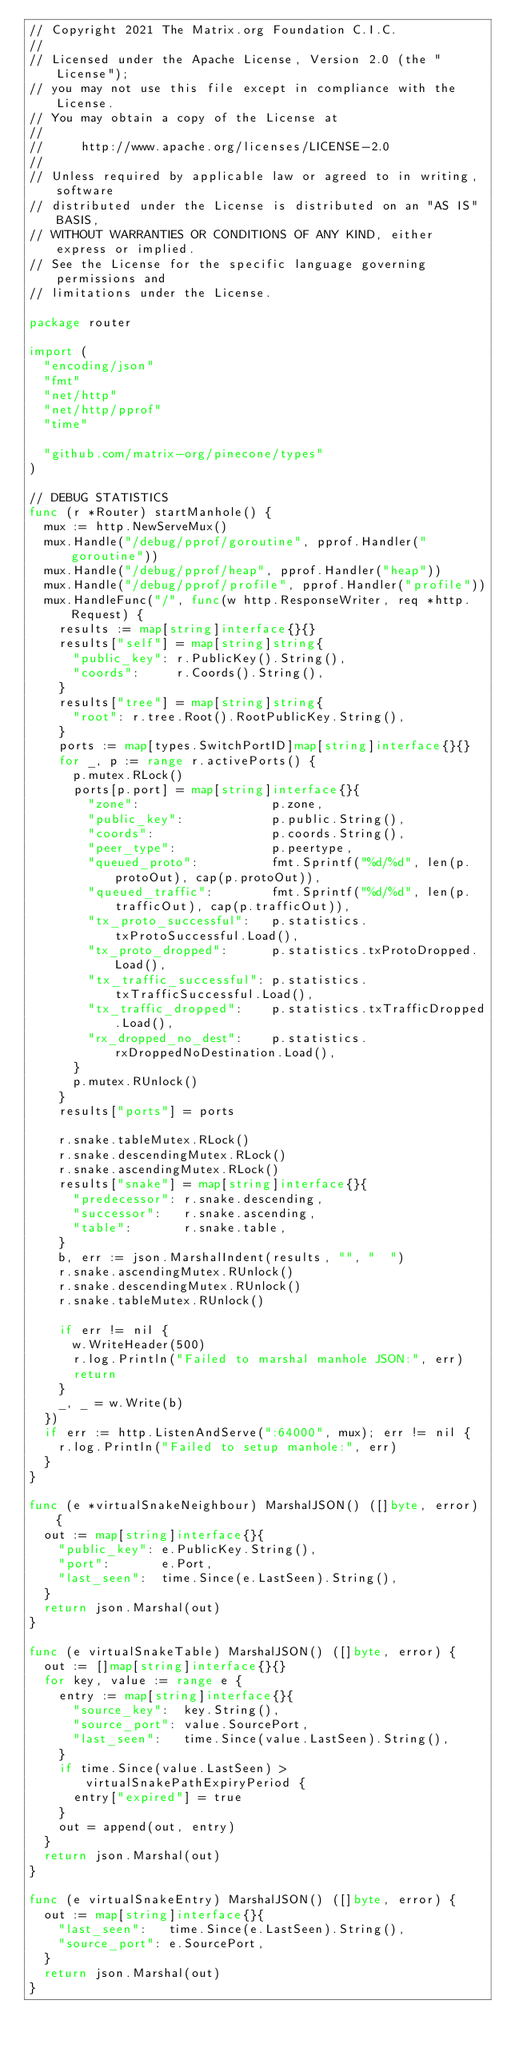<code> <loc_0><loc_0><loc_500><loc_500><_Go_>// Copyright 2021 The Matrix.org Foundation C.I.C.
//
// Licensed under the Apache License, Version 2.0 (the "License");
// you may not use this file except in compliance with the License.
// You may obtain a copy of the License at
//
//     http://www.apache.org/licenses/LICENSE-2.0
//
// Unless required by applicable law or agreed to in writing, software
// distributed under the License is distributed on an "AS IS" BASIS,
// WITHOUT WARRANTIES OR CONDITIONS OF ANY KIND, either express or implied.
// See the License for the specific language governing permissions and
// limitations under the License.

package router

import (
	"encoding/json"
	"fmt"
	"net/http"
	"net/http/pprof"
	"time"

	"github.com/matrix-org/pinecone/types"
)

// DEBUG STATISTICS
func (r *Router) startManhole() {
	mux := http.NewServeMux()
	mux.Handle("/debug/pprof/goroutine", pprof.Handler("goroutine"))
	mux.Handle("/debug/pprof/heap", pprof.Handler("heap"))
	mux.Handle("/debug/pprof/profile", pprof.Handler("profile"))
	mux.HandleFunc("/", func(w http.ResponseWriter, req *http.Request) {
		results := map[string]interface{}{}
		results["self"] = map[string]string{
			"public_key": r.PublicKey().String(),
			"coords":     r.Coords().String(),
		}
		results["tree"] = map[string]string{
			"root": r.tree.Root().RootPublicKey.String(),
		}
		ports := map[types.SwitchPortID]map[string]interface{}{}
		for _, p := range r.activePorts() {
			p.mutex.RLock()
			ports[p.port] = map[string]interface{}{
				"zone":                  p.zone,
				"public_key":            p.public.String(),
				"coords":                p.coords.String(),
				"peer_type":             p.peertype,
				"queued_proto":          fmt.Sprintf("%d/%d", len(p.protoOut), cap(p.protoOut)),
				"queued_traffic":        fmt.Sprintf("%d/%d", len(p.trafficOut), cap(p.trafficOut)),
				"tx_proto_successful":   p.statistics.txProtoSuccessful.Load(),
				"tx_proto_dropped":      p.statistics.txProtoDropped.Load(),
				"tx_traffic_successful": p.statistics.txTrafficSuccessful.Load(),
				"tx_traffic_dropped":    p.statistics.txTrafficDropped.Load(),
				"rx_dropped_no_dest":    p.statistics.rxDroppedNoDestination.Load(),
			}
			p.mutex.RUnlock()
		}
		results["ports"] = ports

		r.snake.tableMutex.RLock()
		r.snake.descendingMutex.RLock()
		r.snake.ascendingMutex.RLock()
		results["snake"] = map[string]interface{}{
			"predecessor": r.snake.descending,
			"successor":   r.snake.ascending,
			"table":       r.snake.table,
		}
		b, err := json.MarshalIndent(results, "", "  ")
		r.snake.ascendingMutex.RUnlock()
		r.snake.descendingMutex.RUnlock()
		r.snake.tableMutex.RUnlock()

		if err != nil {
			w.WriteHeader(500)
			r.log.Println("Failed to marshal manhole JSON:", err)
			return
		}
		_, _ = w.Write(b)
	})
	if err := http.ListenAndServe(":64000", mux); err != nil {
		r.log.Println("Failed to setup manhole:", err)
	}
}

func (e *virtualSnakeNeighbour) MarshalJSON() ([]byte, error) {
	out := map[string]interface{}{
		"public_key": e.PublicKey.String(),
		"port":       e.Port,
		"last_seen":  time.Since(e.LastSeen).String(),
	}
	return json.Marshal(out)
}

func (e virtualSnakeTable) MarshalJSON() ([]byte, error) {
	out := []map[string]interface{}{}
	for key, value := range e {
		entry := map[string]interface{}{
			"source_key":  key.String(),
			"source_port": value.SourcePort,
			"last_seen":   time.Since(value.LastSeen).String(),
		}
		if time.Since(value.LastSeen) > virtualSnakePathExpiryPeriod {
			entry["expired"] = true
		}
		out = append(out, entry)
	}
	return json.Marshal(out)
}

func (e virtualSnakeEntry) MarshalJSON() ([]byte, error) {
	out := map[string]interface{}{
		"last_seen":   time.Since(e.LastSeen).String(),
		"source_port": e.SourcePort,
	}
	return json.Marshal(out)
}
</code> 